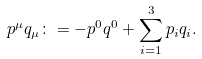Convert formula to latex. <formula><loc_0><loc_0><loc_500><loc_500>p ^ { \mu } q _ { \mu } \colon = - p ^ { 0 } q ^ { 0 } + \sum _ { i = 1 } ^ { 3 } p _ { i } q _ { i } .</formula> 